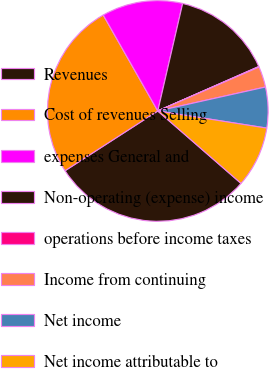Convert chart to OTSL. <chart><loc_0><loc_0><loc_500><loc_500><pie_chart><fcel>Revenues<fcel>Cost of revenues Selling<fcel>expenses General and<fcel>Non-operating (expense) income<fcel>operations before income taxes<fcel>Income from continuing<fcel>Net income<fcel>Net income attributable to<nl><fcel>29.5%<fcel>25.88%<fcel>11.85%<fcel>14.79%<fcel>0.08%<fcel>3.03%<fcel>5.97%<fcel>8.91%<nl></chart> 